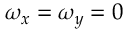Convert formula to latex. <formula><loc_0><loc_0><loc_500><loc_500>\omega _ { x } = \omega _ { y } = 0</formula> 